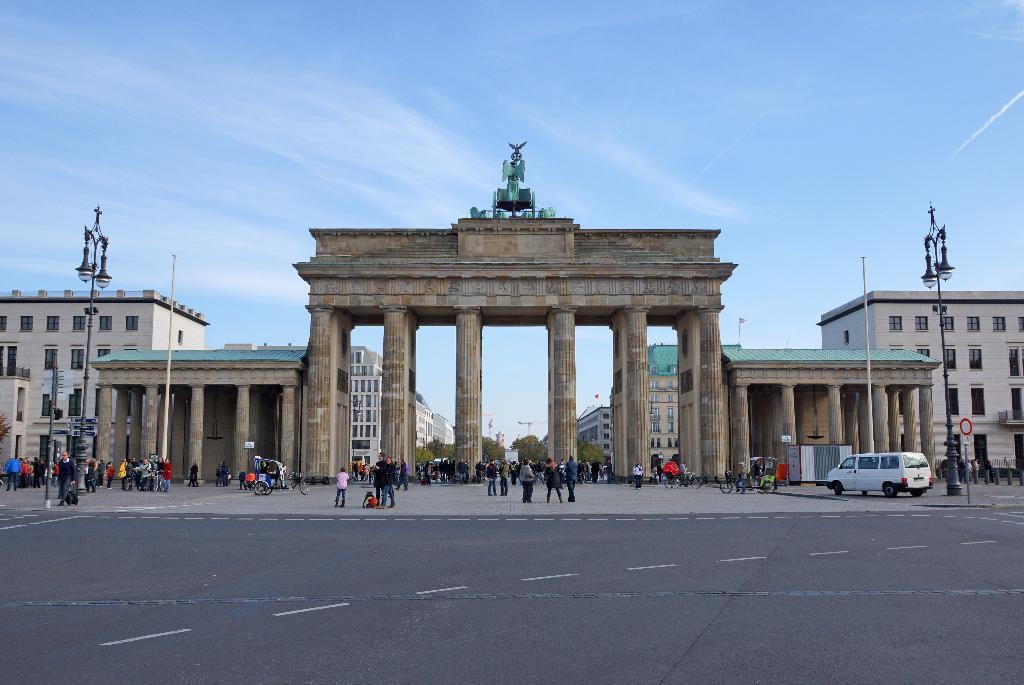Can you describe this image briefly? In this picture I can see buildings, couple of pole lights and poles and I can see few people standing and a vehicle on the right side. I can see trees and an arch and I can see sculpture and a blue cloudy sky. 